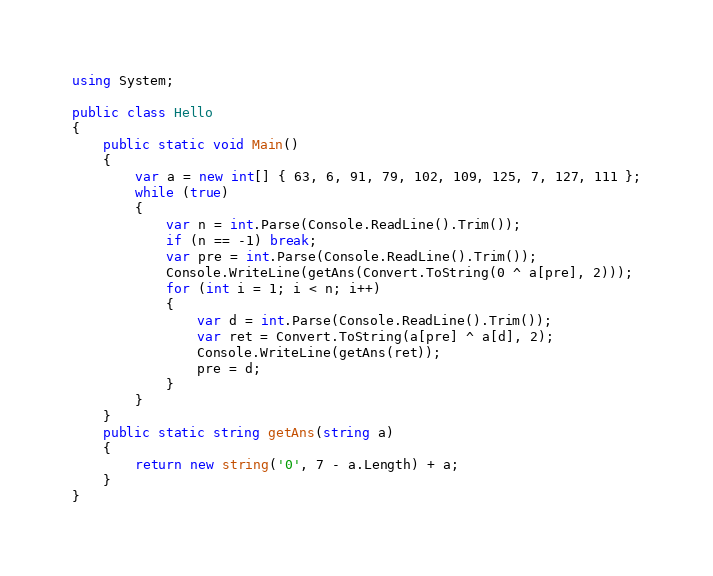Convert code to text. <code><loc_0><loc_0><loc_500><loc_500><_C#_>using System;

public class Hello
{
    public static void Main()
    {
        var a = new int[] { 63, 6, 91, 79, 102, 109, 125, 7, 127, 111 };
        while (true)
        {
            var n = int.Parse(Console.ReadLine().Trim());
            if (n == -1) break;
            var pre = int.Parse(Console.ReadLine().Trim());
            Console.WriteLine(getAns(Convert.ToString(0 ^ a[pre], 2)));
            for (int i = 1; i < n; i++)
            {
                var d = int.Parse(Console.ReadLine().Trim());
                var ret = Convert.ToString(a[pre] ^ a[d], 2);
                Console.WriteLine(getAns(ret));
                pre = d;
            }
        }
    }
    public static string getAns(string a)
    {
        return new string('0', 7 - a.Length) + a;
    }
}

</code> 